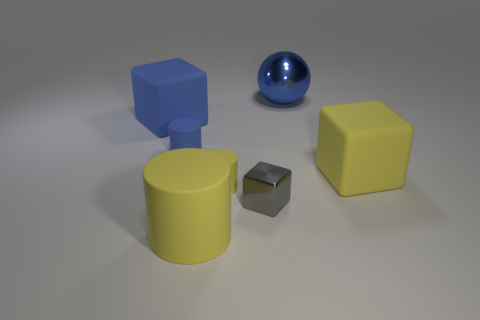What number of small gray cubes have the same material as the tiny blue thing?
Offer a terse response. 0. Are there more small brown metallic objects than large matte cylinders?
Your answer should be very brief. No. There is a large metal thing that is behind the tiny shiny block; what number of large blue rubber blocks are to the left of it?
Your answer should be very brief. 1. What number of things are either yellow objects that are on the left side of the metal sphere or blue matte things?
Keep it short and to the point. 4. Are there any other small things that have the same shape as the small blue object?
Your answer should be compact. Yes. What is the shape of the large yellow matte thing on the left side of the rubber block on the right side of the large blue shiny ball?
Offer a terse response. Cylinder. How many balls are shiny things or tiny matte things?
Your response must be concise. 1. Is the shape of the large yellow rubber thing that is right of the small gray cube the same as the metallic object that is in front of the blue matte cube?
Ensure brevity in your answer.  Yes. What color is the cylinder that is both in front of the large yellow rubber block and behind the big yellow matte cylinder?
Your answer should be very brief. Yellow. There is a small shiny block; does it have the same color as the rubber thing that is right of the blue ball?
Give a very brief answer. No. 